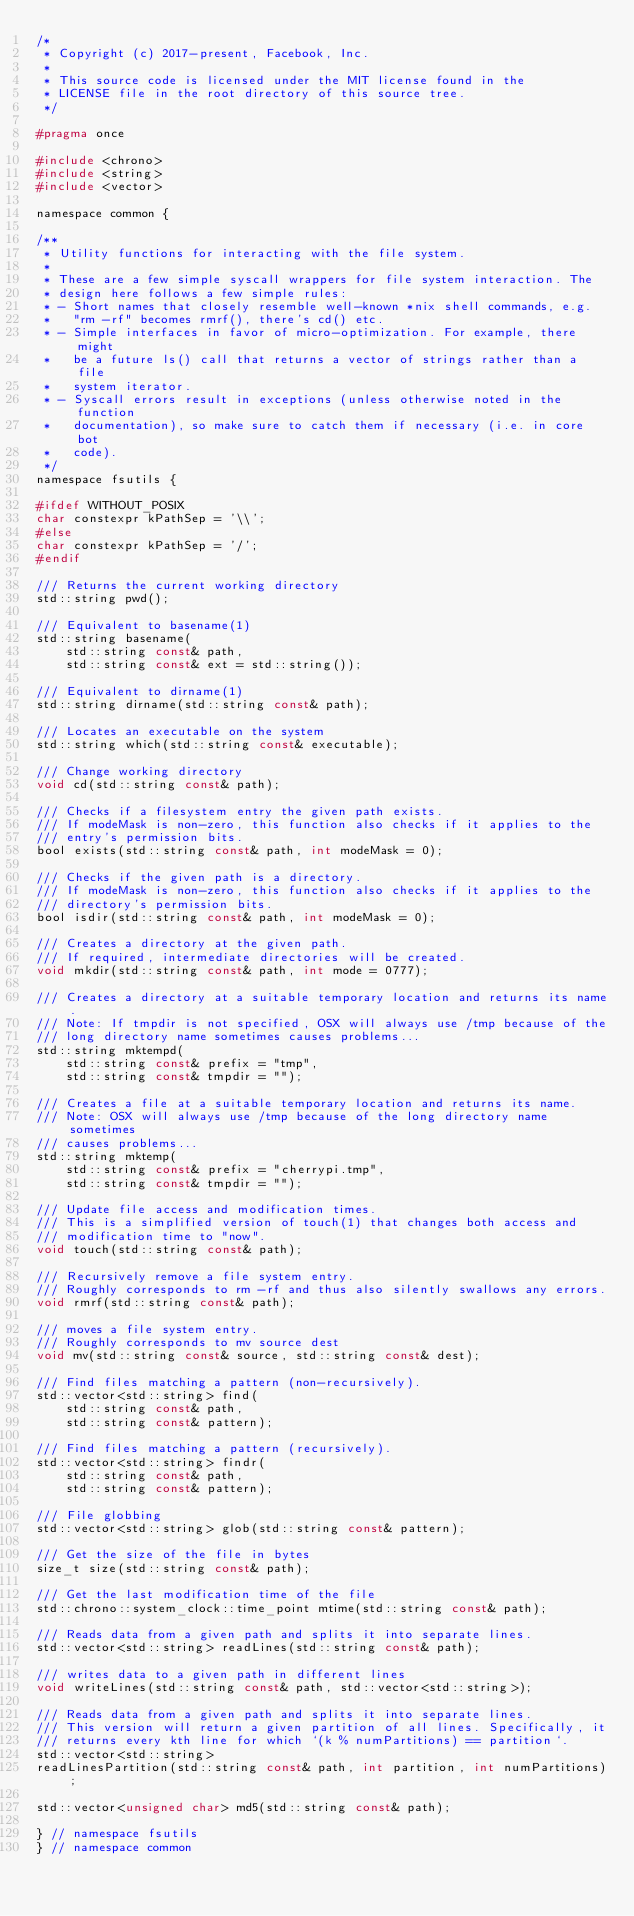Convert code to text. <code><loc_0><loc_0><loc_500><loc_500><_C_>/*
 * Copyright (c) 2017-present, Facebook, Inc.
 *
 * This source code is licensed under the MIT license found in the
 * LICENSE file in the root directory of this source tree.
 */

#pragma once

#include <chrono>
#include <string>
#include <vector>

namespace common {

/**
 * Utility functions for interacting with the file system.
 *
 * These are a few simple syscall wrappers for file system interaction. The
 * design here follows a few simple rules:
 * - Short names that closely resemble well-known *nix shell commands, e.g.
 *   "rm -rf" becomes rmrf(), there's cd() etc.
 * - Simple interfaces in favor of micro-optimization. For example, there might
 *   be a future ls() call that returns a vector of strings rather than a file
 *   system iterator.
 * - Syscall errors result in exceptions (unless otherwise noted in the function
 *   documentation), so make sure to catch them if necessary (i.e. in core bot
 *   code).
 */
namespace fsutils {

#ifdef WITHOUT_POSIX
char constexpr kPathSep = '\\';
#else
char constexpr kPathSep = '/';
#endif

/// Returns the current working directory
std::string pwd();

/// Equivalent to basename(1)
std::string basename(
    std::string const& path,
    std::string const& ext = std::string());

/// Equivalent to dirname(1)
std::string dirname(std::string const& path);

/// Locates an executable on the system
std::string which(std::string const& executable);

/// Change working directory
void cd(std::string const& path);

/// Checks if a filesystem entry the given path exists.
/// If modeMask is non-zero, this function also checks if it applies to the
/// entry's permission bits.
bool exists(std::string const& path, int modeMask = 0);

/// Checks if the given path is a directory.
/// If modeMask is non-zero, this function also checks if it applies to the
/// directory's permission bits.
bool isdir(std::string const& path, int modeMask = 0);

/// Creates a directory at the given path.
/// If required, intermediate directories will be created.
void mkdir(std::string const& path, int mode = 0777);

/// Creates a directory at a suitable temporary location and returns its name.
/// Note: If tmpdir is not specified, OSX will always use /tmp because of the
/// long directory name sometimes causes problems...
std::string mktempd(
    std::string const& prefix = "tmp",
    std::string const& tmpdir = "");

/// Creates a file at a suitable temporary location and returns its name.
/// Note: OSX will always use /tmp because of the long directory name sometimes
/// causes problems...
std::string mktemp(
    std::string const& prefix = "cherrypi.tmp",
    std::string const& tmpdir = "");

/// Update file access and modification times.
/// This is a simplified version of touch(1) that changes both access and
/// modification time to "now".
void touch(std::string const& path);

/// Recursively remove a file system entry.
/// Roughly corresponds to rm -rf and thus also silently swallows any errors.
void rmrf(std::string const& path);

/// moves a file system entry.
/// Roughly corresponds to mv source dest
void mv(std::string const& source, std::string const& dest);

/// Find files matching a pattern (non-recursively).
std::vector<std::string> find(
    std::string const& path,
    std::string const& pattern);

/// Find files matching a pattern (recursively).
std::vector<std::string> findr(
    std::string const& path,
    std::string const& pattern);

/// File globbing
std::vector<std::string> glob(std::string const& pattern);

/// Get the size of the file in bytes
size_t size(std::string const& path);

/// Get the last modification time of the file
std::chrono::system_clock::time_point mtime(std::string const& path);

/// Reads data from a given path and splits it into separate lines.
std::vector<std::string> readLines(std::string const& path);

/// writes data to a given path in different lines
void writeLines(std::string const& path, std::vector<std::string>);

/// Reads data from a given path and splits it into separate lines.
/// This version will return a given partition of all lines. Specifically, it
/// returns every kth line for which `(k % numPartitions) == partition`.
std::vector<std::string>
readLinesPartition(std::string const& path, int partition, int numPartitions);

std::vector<unsigned char> md5(std::string const& path);

} // namespace fsutils
} // namespace common
</code> 